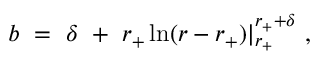Convert formula to latex. <formula><loc_0><loc_0><loc_500><loc_500>b = \delta + r _ { + } \ln ( r - r _ { + } ) | _ { r _ { + } } ^ { r _ { + } + \delta } ,</formula> 